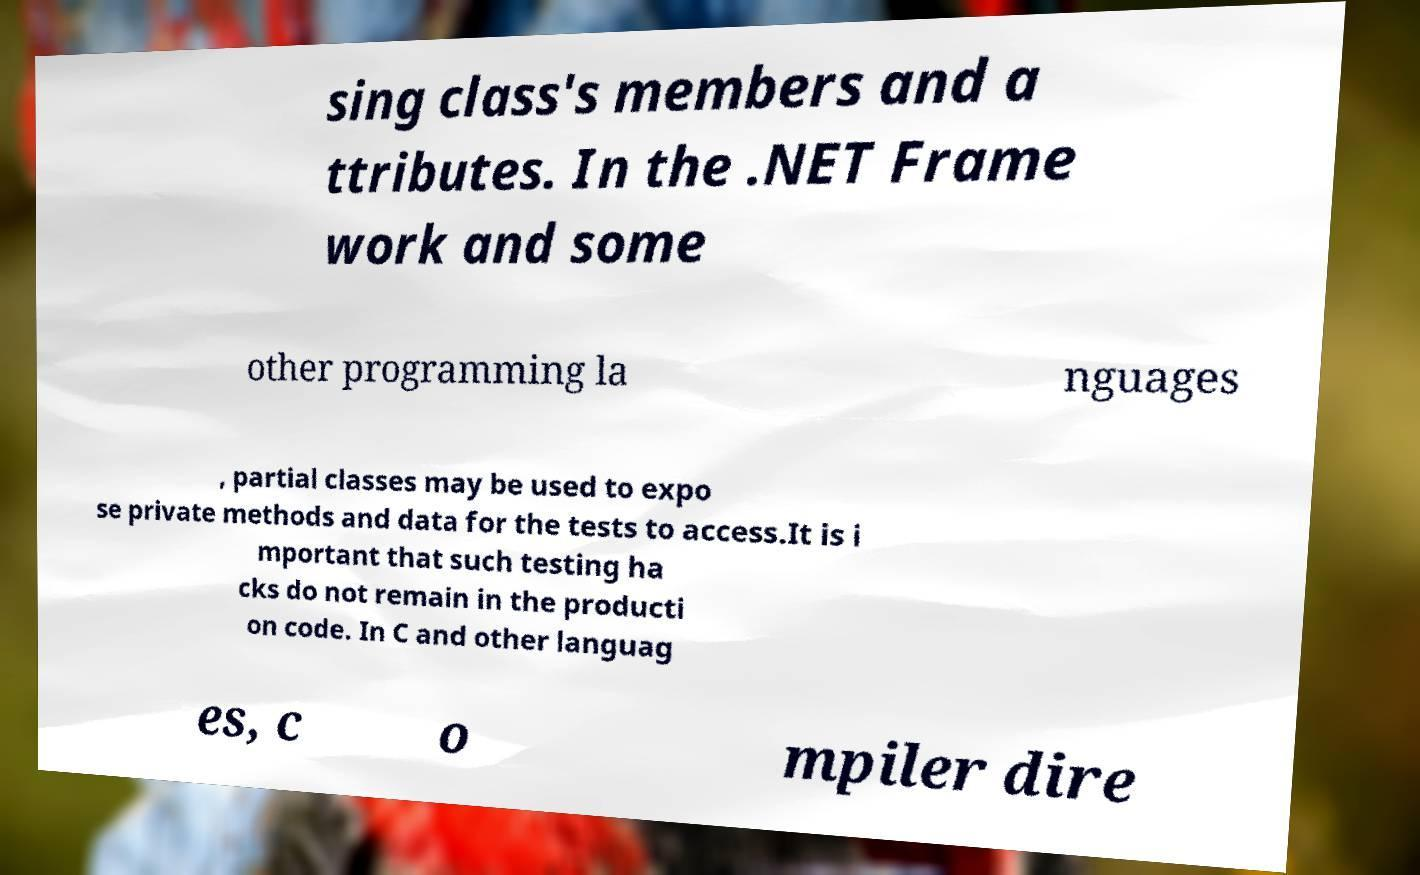Can you accurately transcribe the text from the provided image for me? sing class's members and a ttributes. In the .NET Frame work and some other programming la nguages , partial classes may be used to expo se private methods and data for the tests to access.It is i mportant that such testing ha cks do not remain in the producti on code. In C and other languag es, c o mpiler dire 